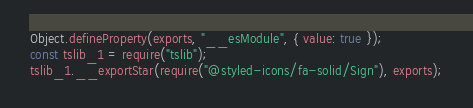Convert code to text. <code><loc_0><loc_0><loc_500><loc_500><_JavaScript_>Object.defineProperty(exports, "__esModule", { value: true });
const tslib_1 = require("tslib");
tslib_1.__exportStar(require("@styled-icons/fa-solid/Sign"), exports);
</code> 